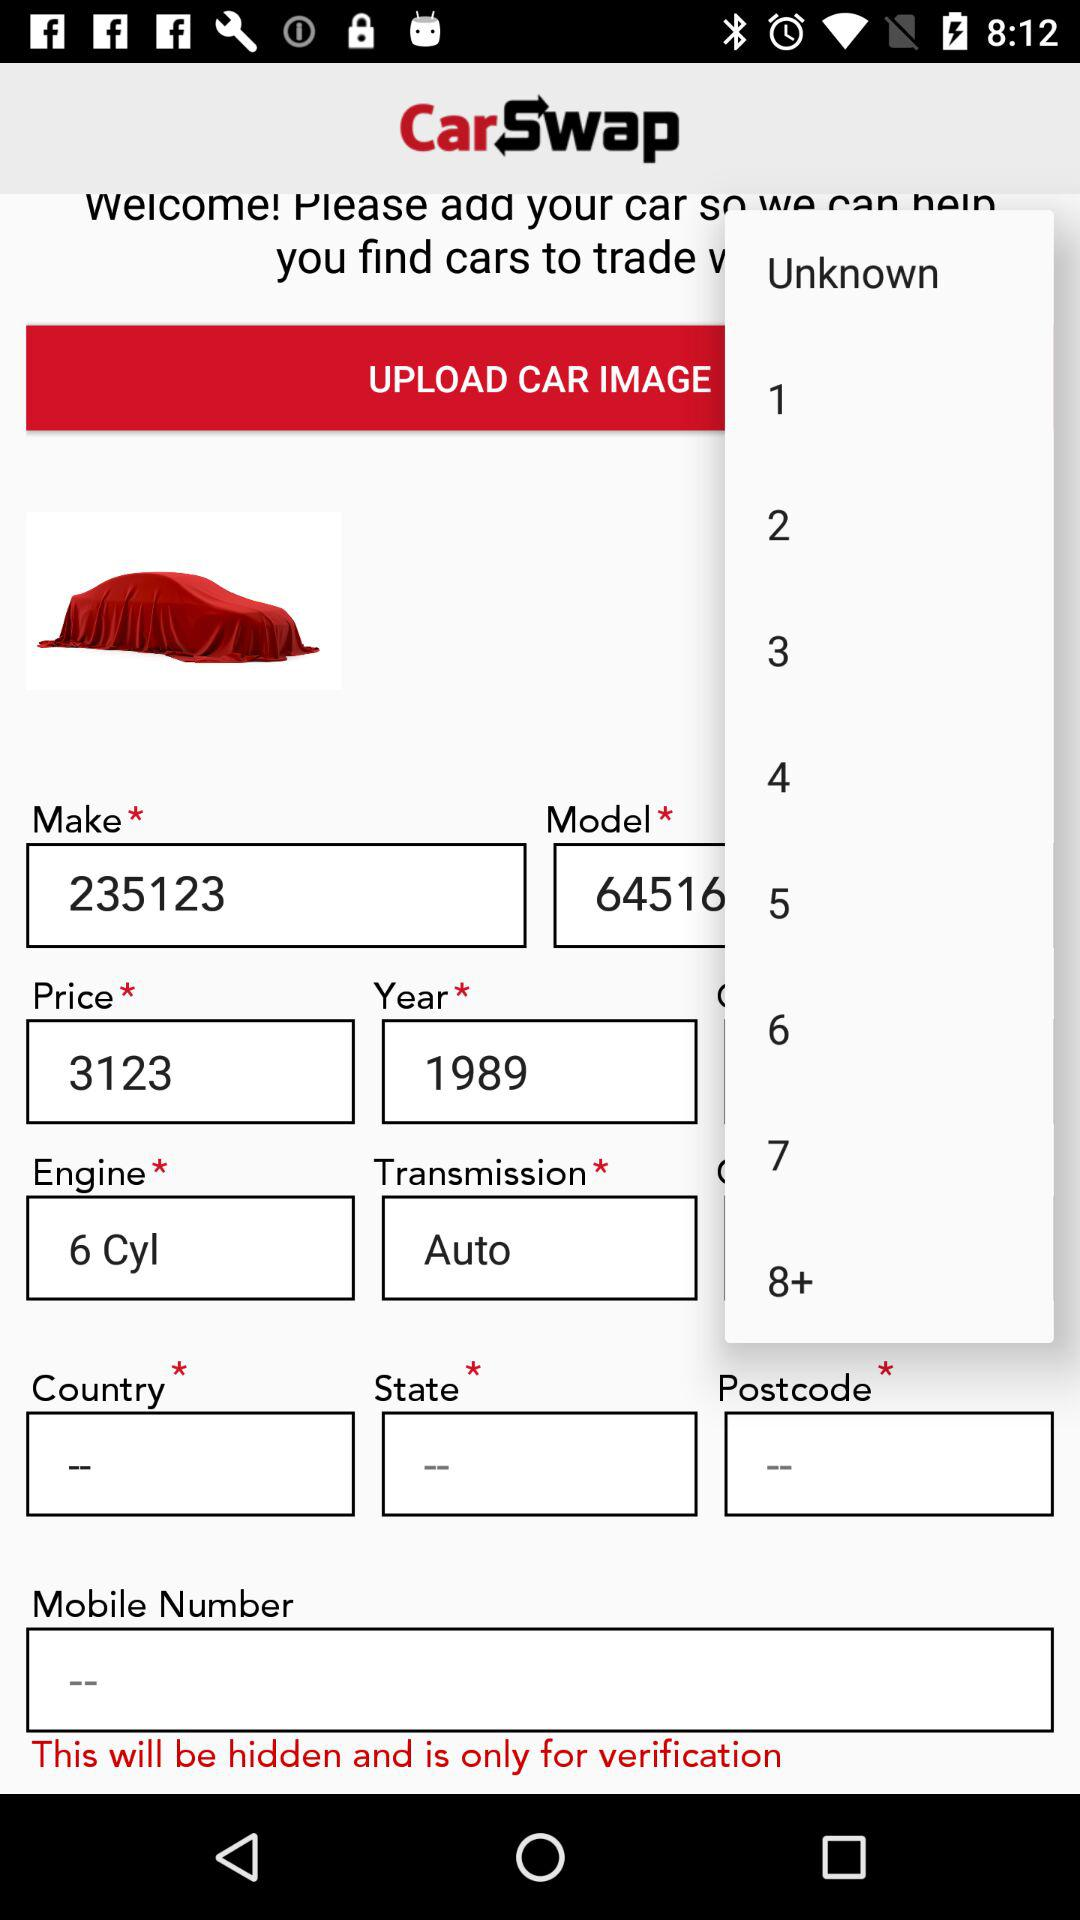What is the type of engine? The type of engine is "6 Cyl". 